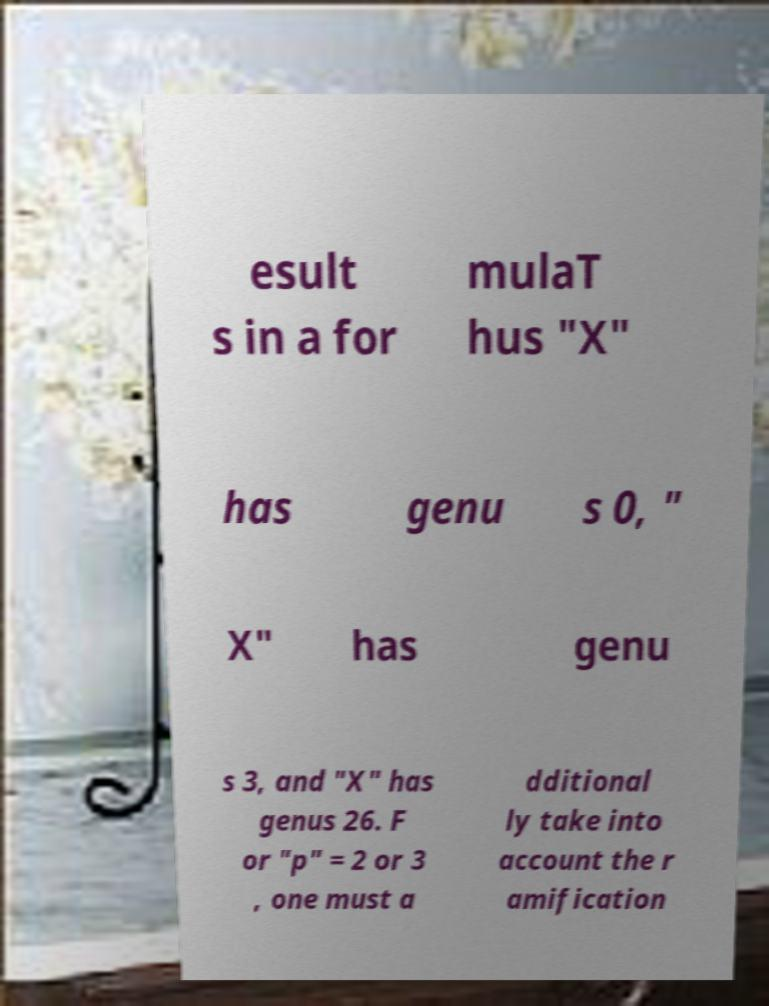Please identify and transcribe the text found in this image. esult s in a for mulaT hus "X" has genu s 0, " X" has genu s 3, and "X" has genus 26. F or "p" = 2 or 3 , one must a dditional ly take into account the r amification 